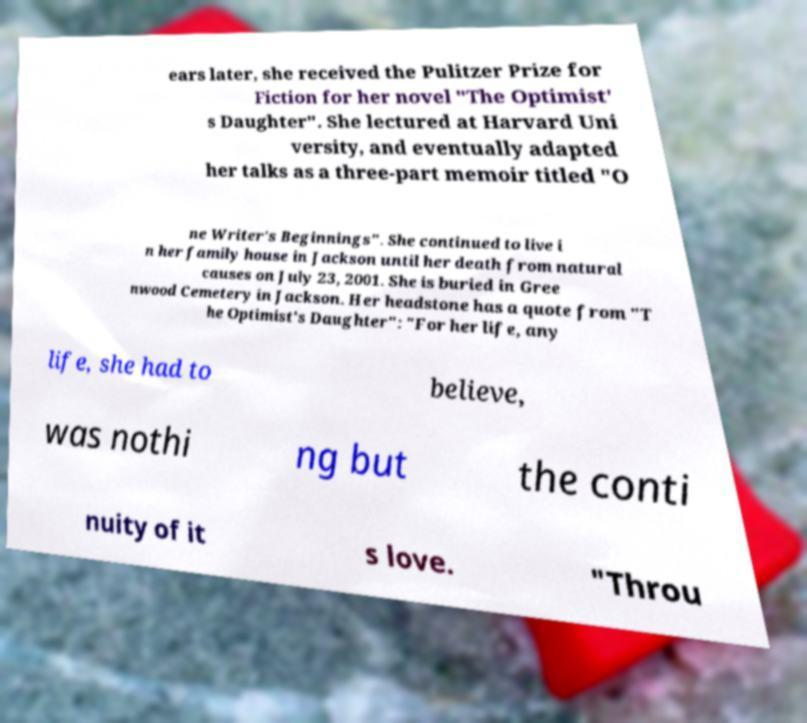Can you read and provide the text displayed in the image?This photo seems to have some interesting text. Can you extract and type it out for me? ears later, she received the Pulitzer Prize for Fiction for her novel "The Optimist' s Daughter". She lectured at Harvard Uni versity, and eventually adapted her talks as a three-part memoir titled "O ne Writer's Beginnings". She continued to live i n her family house in Jackson until her death from natural causes on July 23, 2001. She is buried in Gree nwood Cemetery in Jackson. Her headstone has a quote from "T he Optimist's Daughter": "For her life, any life, she had to believe, was nothi ng but the conti nuity of it s love. "Throu 